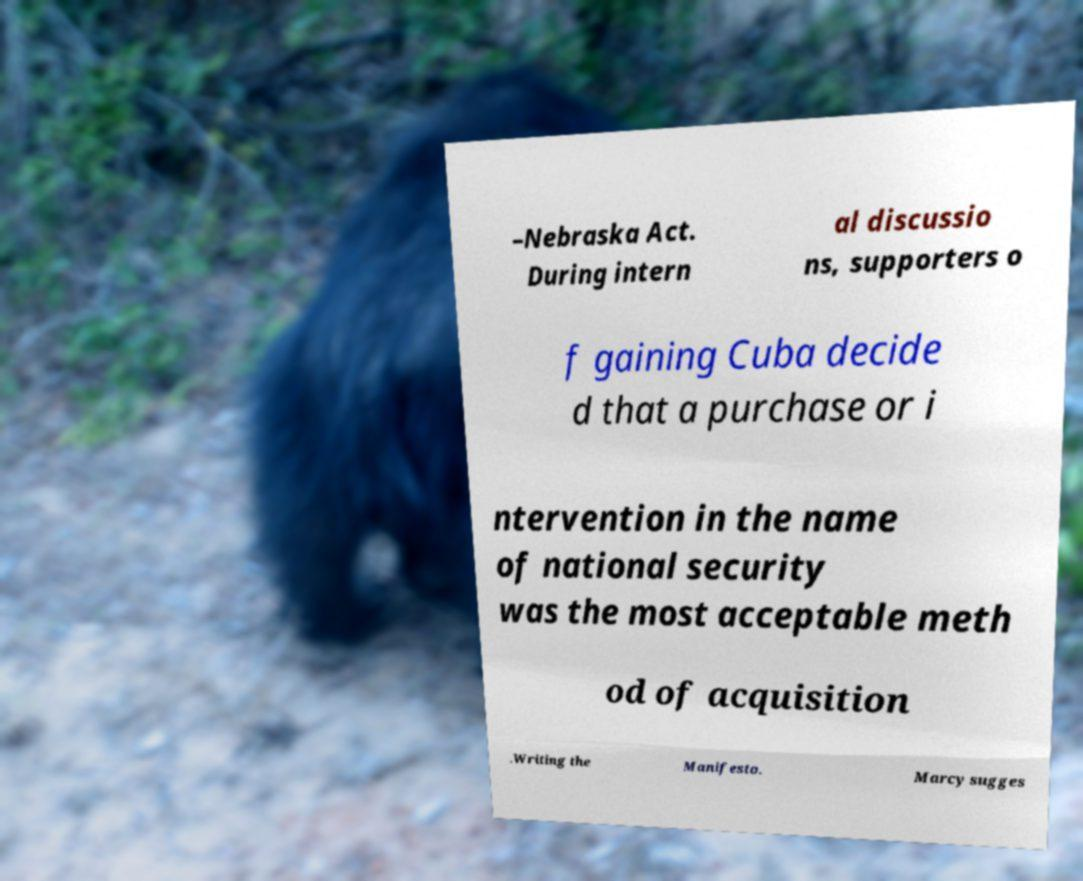Can you read and provide the text displayed in the image?This photo seems to have some interesting text. Can you extract and type it out for me? –Nebraska Act. During intern al discussio ns, supporters o f gaining Cuba decide d that a purchase or i ntervention in the name of national security was the most acceptable meth od of acquisition .Writing the Manifesto. Marcy sugges 